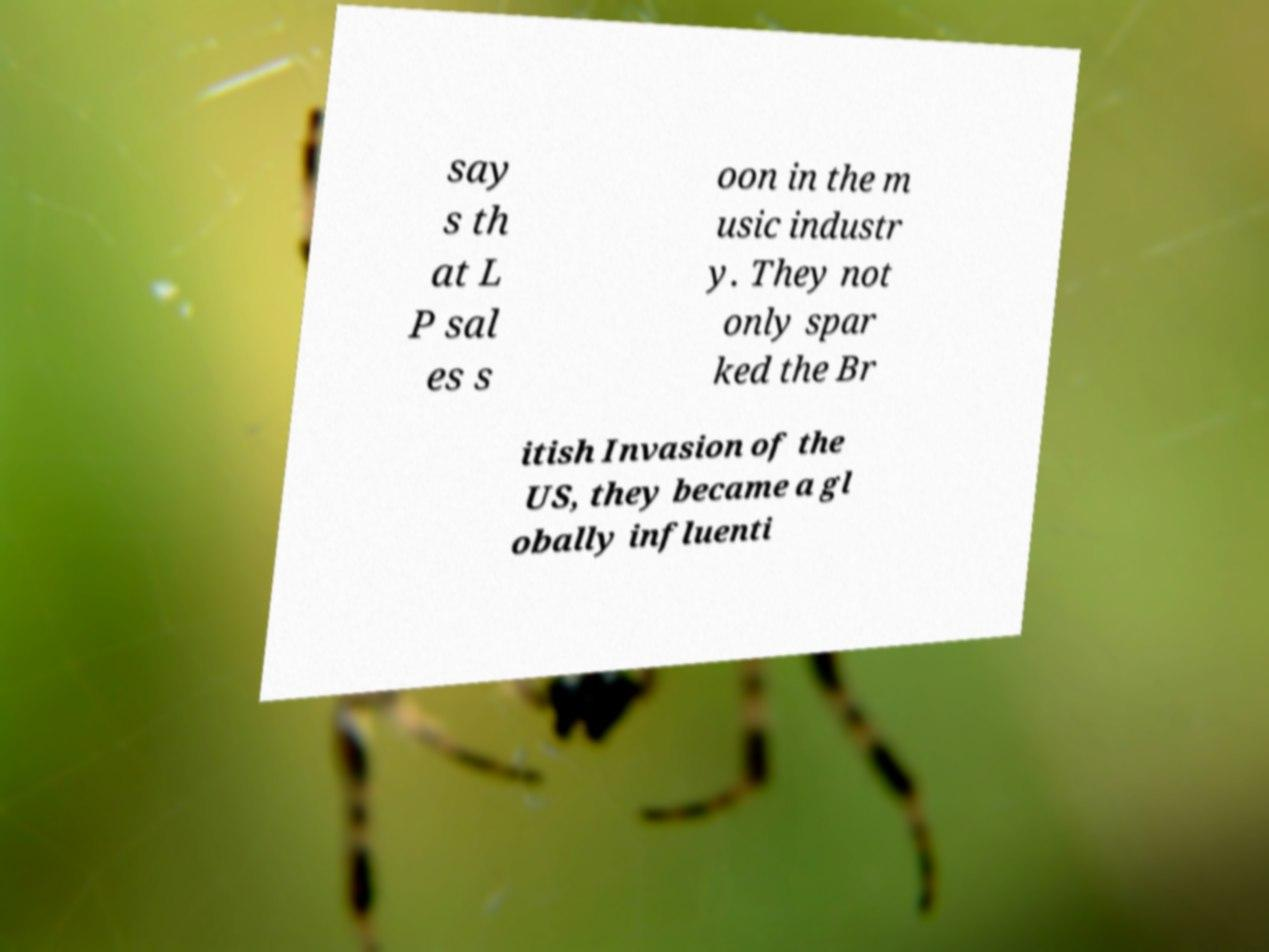Could you assist in decoding the text presented in this image and type it out clearly? say s th at L P sal es s oon in the m usic industr y. They not only spar ked the Br itish Invasion of the US, they became a gl obally influenti 